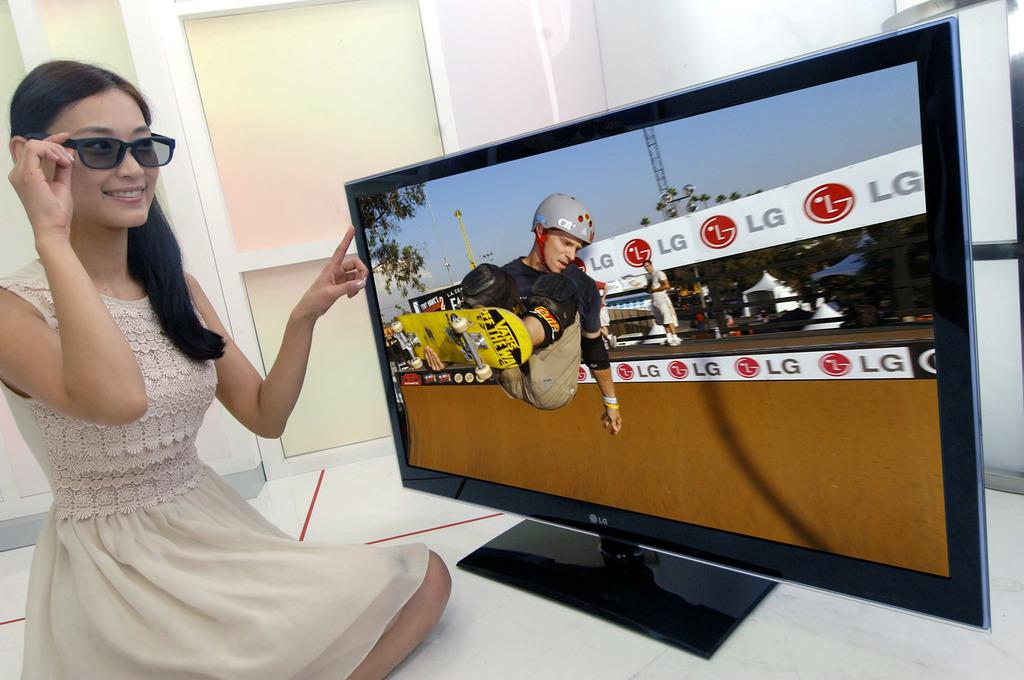Provide a one-sentence caption for the provided image. A woman wearing glasses sits in front of an LG television watching a skateboarder. 